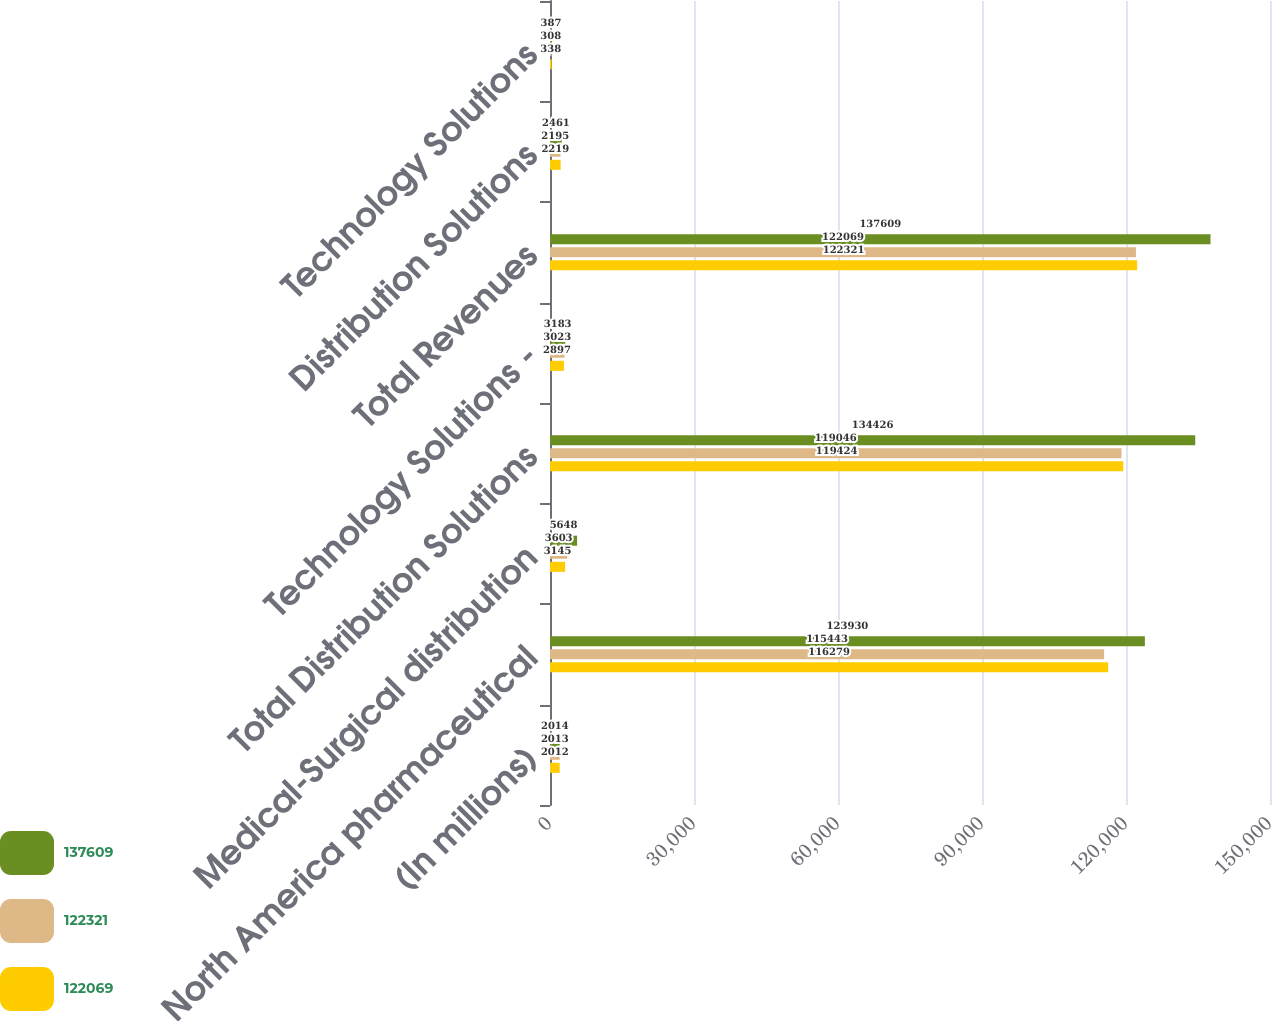Convert chart to OTSL. <chart><loc_0><loc_0><loc_500><loc_500><stacked_bar_chart><ecel><fcel>(In millions)<fcel>North America pharmaceutical<fcel>Medical-Surgical distribution<fcel>Total Distribution Solutions<fcel>Technology Solutions -<fcel>Total Revenues<fcel>Distribution Solutions<fcel>Technology Solutions<nl><fcel>137609<fcel>2014<fcel>123930<fcel>5648<fcel>134426<fcel>3183<fcel>137609<fcel>2461<fcel>387<nl><fcel>122321<fcel>2013<fcel>115443<fcel>3603<fcel>119046<fcel>3023<fcel>122069<fcel>2195<fcel>308<nl><fcel>122069<fcel>2012<fcel>116279<fcel>3145<fcel>119424<fcel>2897<fcel>122321<fcel>2219<fcel>338<nl></chart> 